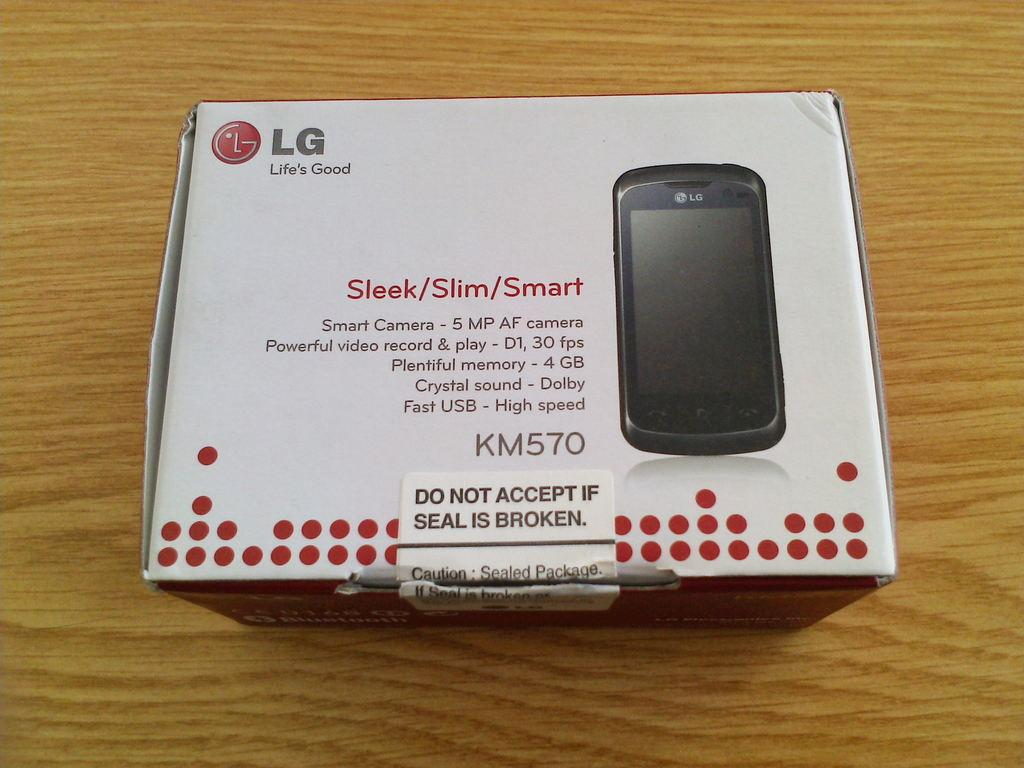<image>
Create a compact narrative representing the image presented. A new cell phone with KM570 on iy 